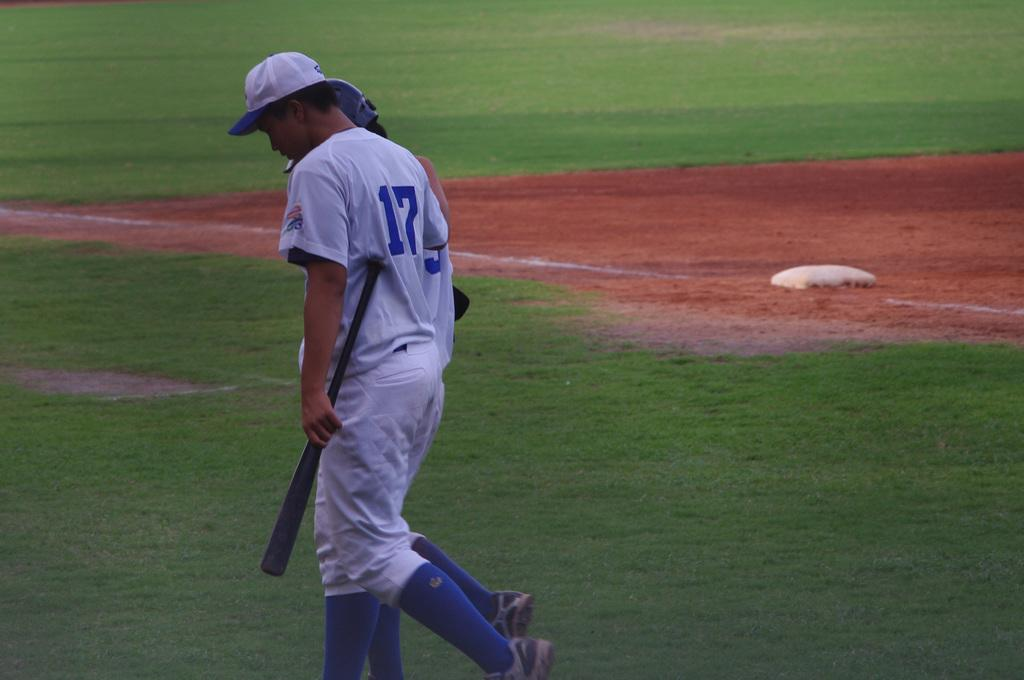<image>
Render a clear and concise summary of the photo. Number 17 baseball player holding bat dejectedly walking on playing field. 